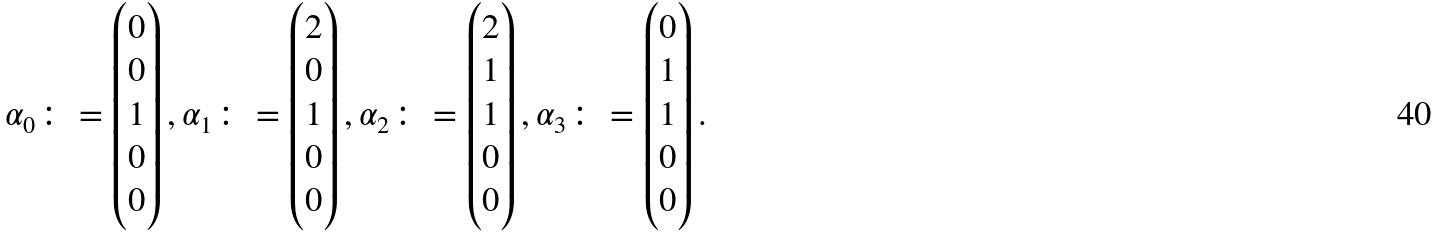<formula> <loc_0><loc_0><loc_500><loc_500>\alpha _ { 0 } \colon = \begin{pmatrix} 0 \\ 0 \\ 1 \\ 0 \\ 0 \end{pmatrix} , \alpha _ { 1 } \colon = \begin{pmatrix} 2 \\ 0 \\ 1 \\ 0 \\ 0 \end{pmatrix} , \alpha _ { 2 } \colon = \begin{pmatrix} 2 \\ 1 \\ 1 \\ 0 \\ 0 \end{pmatrix} , \alpha _ { 3 } \colon = \begin{pmatrix} 0 \\ 1 \\ 1 \\ 0 \\ 0 \end{pmatrix} .</formula> 